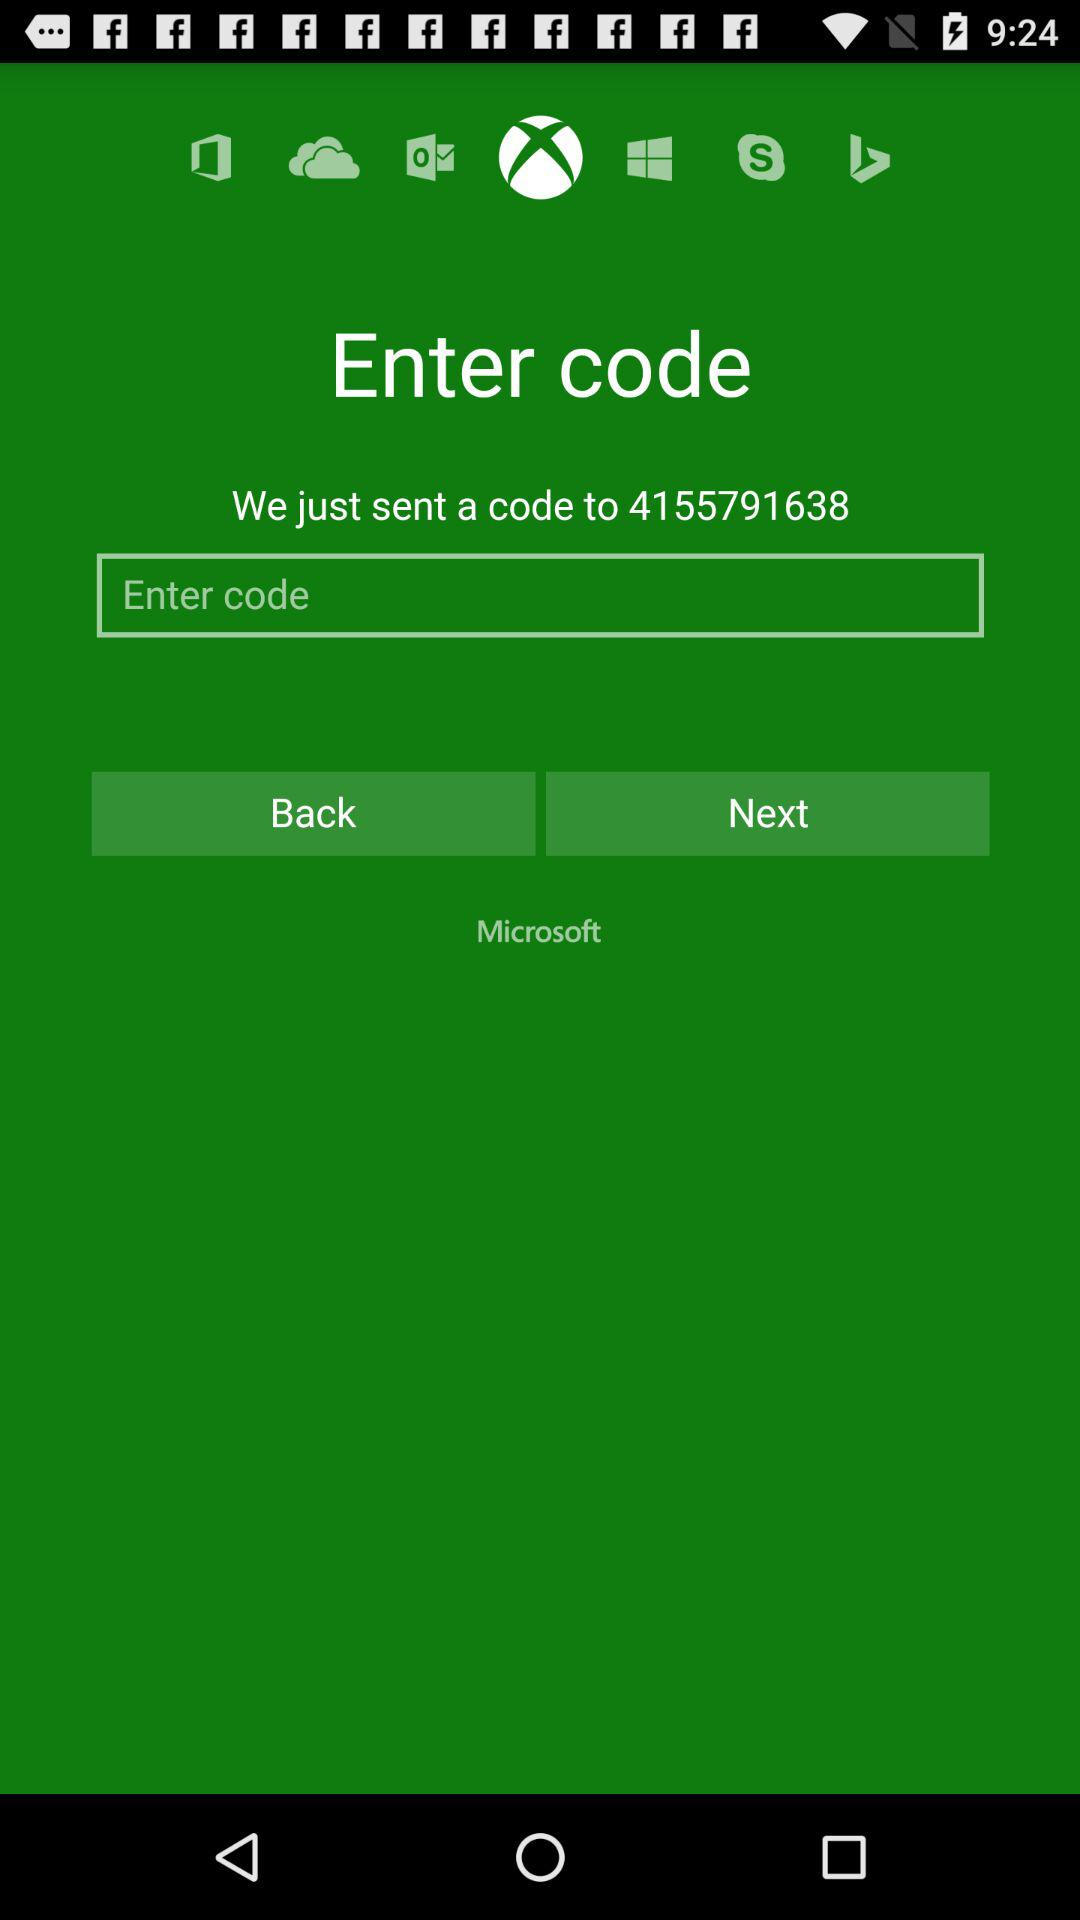To what number is the code sent? The code is sent to 4155791638. 